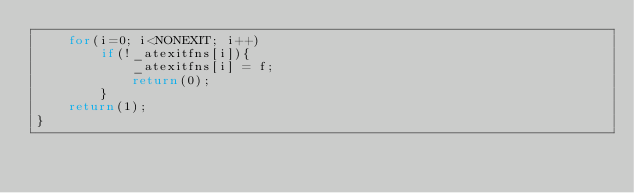Convert code to text. <code><loc_0><loc_0><loc_500><loc_500><_C_>	for(i=0; i<NONEXIT; i++)
		if(!_atexitfns[i]){
			_atexitfns[i] = f;
			return(0);
		}
	return(1);
}
</code> 